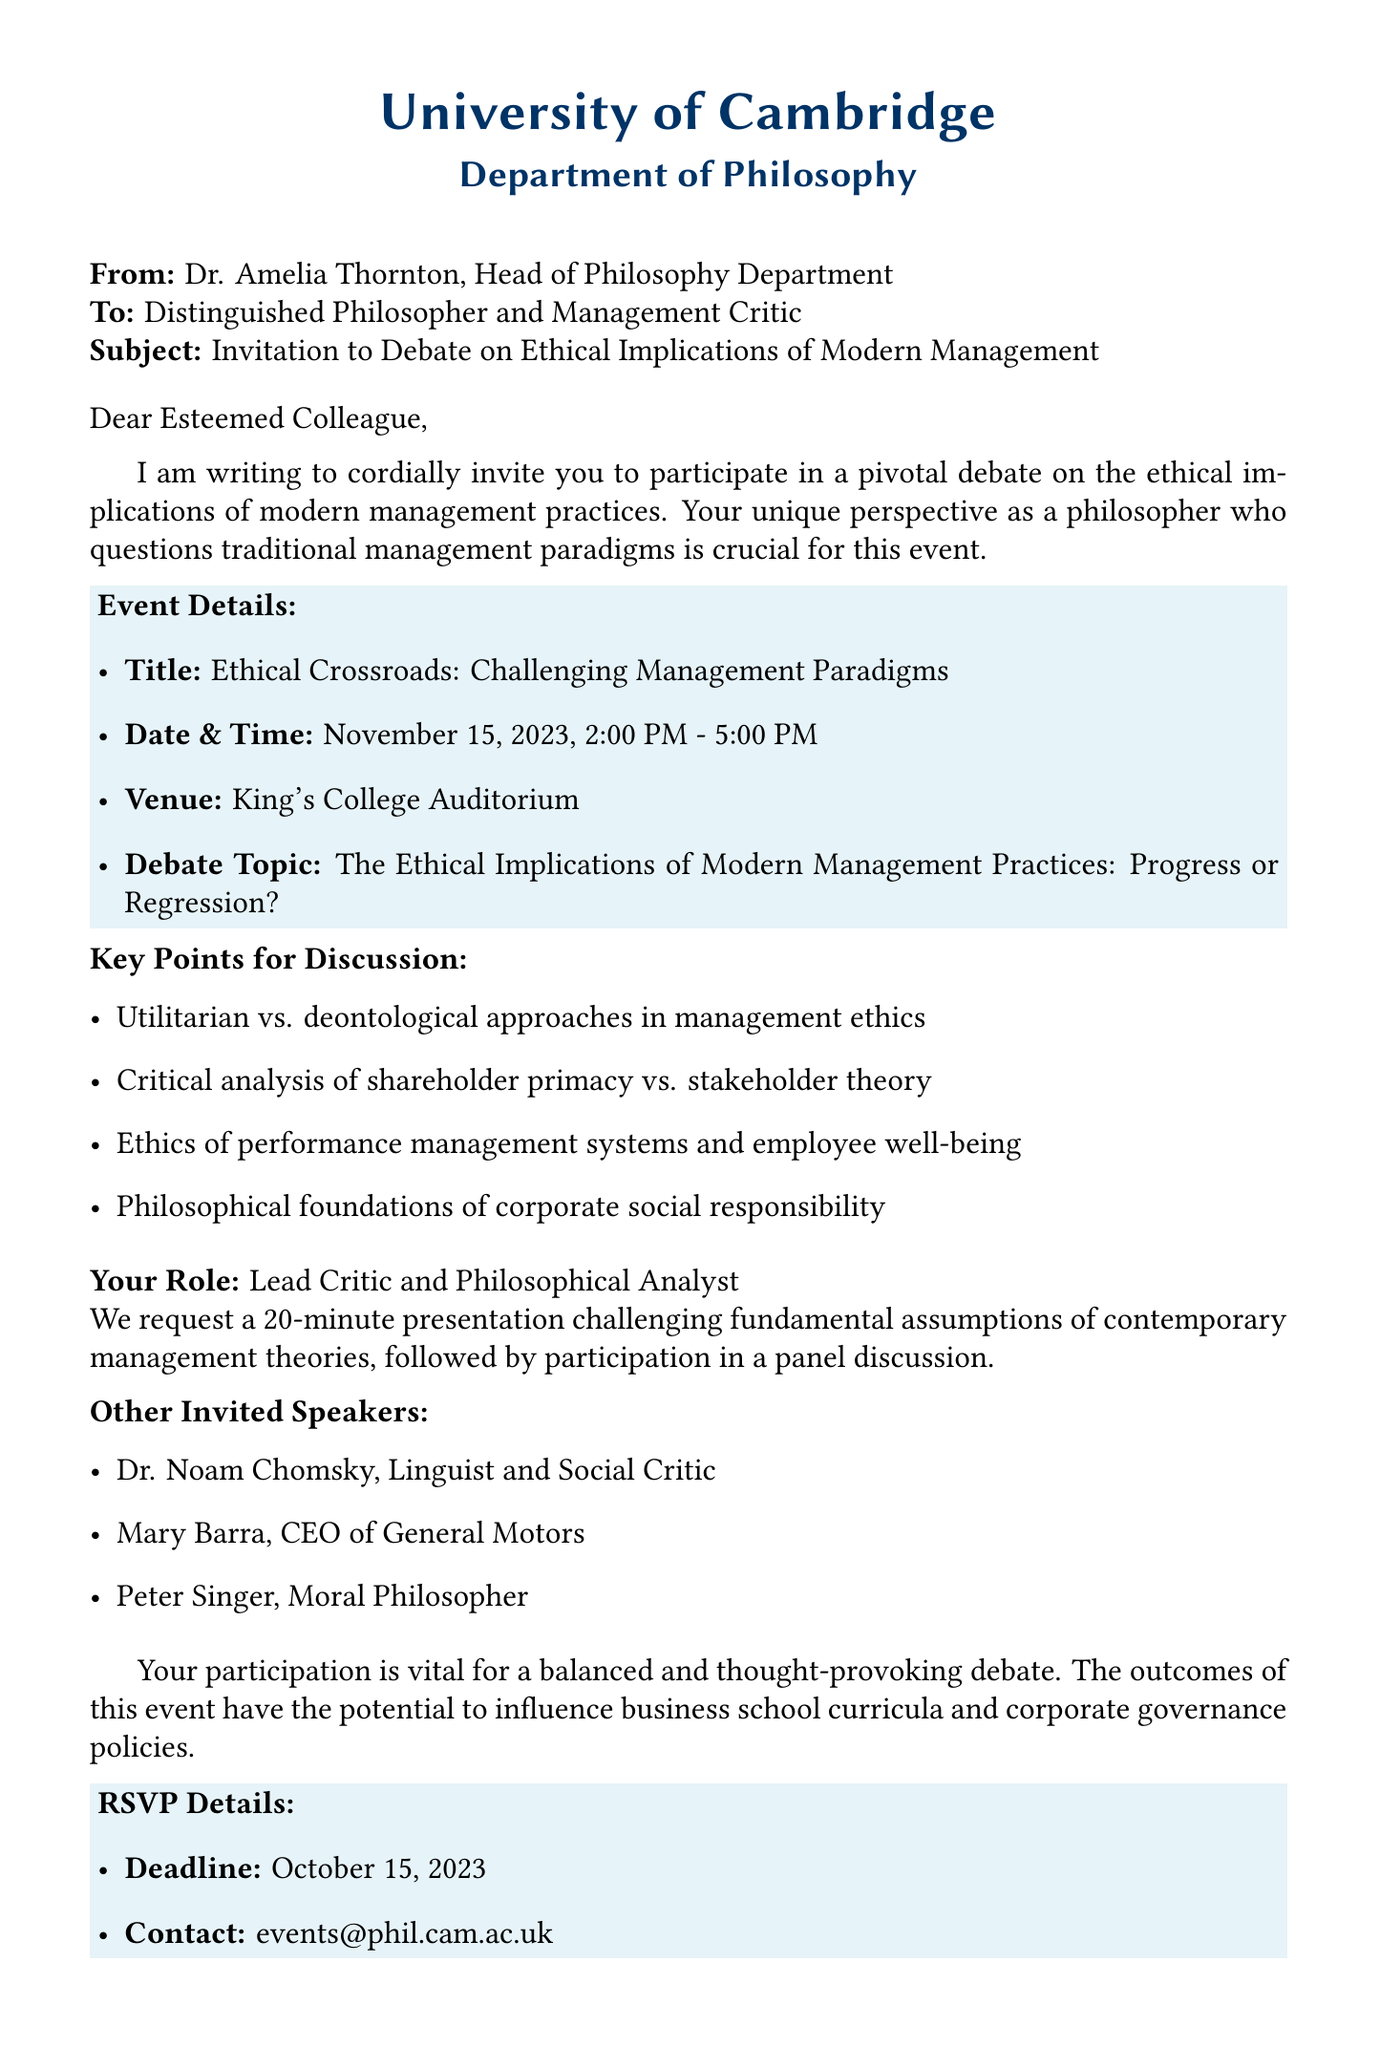What is the name of the sender? The sender of the document is Dr. Amelia Thornton, as mentioned at the beginning of the document.
Answer: Dr. Amelia Thornton What is the date of the event? The event is scheduled for November 15, 2023, as indicated in the event details.
Answer: November 15, 2023 What is the main topic of the debate? The debate topic is outlined in the document, which asks about the ethical implications of management practices.
Answer: The Ethical Implications of Modern Management Practices: Progress or Regression? Who are the invited speakers? The document lists three invited speakers, including notable figures relevant to the topic.
Answer: Dr. Noam Chomsky, Mary Barra, Peter Singer What is your expected role in the event? The document specifies that the recipient is invited to take on a particular role in the debate.
Answer: Lead Critic and Philosophical Analyst What are the key points for discussion? The document lists several key points that will be discussed during the debate.
Answer: Utilitarian vs. deontological approaches in management ethics What is the deadline for RSVP? The deadline for responding to the invitation is stated clearly in the RSVP details section.
Answer: October 15, 2023 What is the venue for the event? The document provides the location where the event will take place.
Answer: King's College Auditorium How long is the presentation expected to be? The expected duration of the presentation is specified in the document.
Answer: 20 minutes 